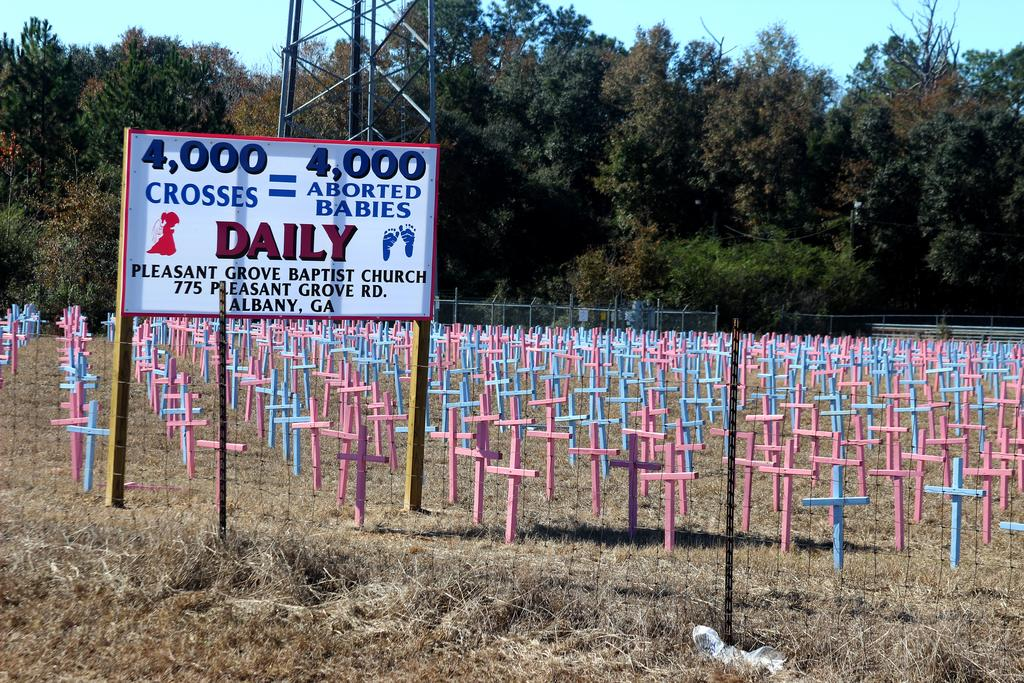What objects can be seen in the image? There are rods, a board, and crosses in the image. What is the ground like in the image? The ground is visible in the image. What architectural feature can be seen in the image? There is a fence in the image. What can be seen in the background of the image? There are trees, a tower, and the sky visible in the background of the image. How many coaches are parked near the trees in the image? There are no coaches present in the image. Is there a camp set up near the tower in the image? There is no camp visible in the image. 